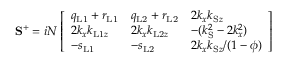Convert formula to latex. <formula><loc_0><loc_0><loc_500><loc_500>S ^ { + } = i N \left [ \begin{array} { l l l } { q _ { L 1 } + r _ { L 1 } } & { q _ { L 2 } + r _ { L 2 } } & { 2 k _ { x } k _ { S z } } \\ { 2 k _ { x } k _ { L 1 z } } & { 2 k _ { x } k _ { L 2 z } } & { - ( k _ { S } ^ { 2 } - 2 k _ { x } ^ { 2 } ) } \\ { - s _ { L 1 } } & { - s _ { L 2 } } & { 2 k _ { x } k _ { S z } / ( 1 - \phi ) } \end{array} \right ]</formula> 